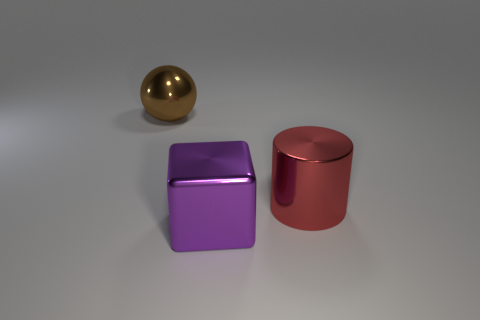What is the big thing that is in front of the large object that is to the right of the large object that is in front of the red cylinder made of?
Give a very brief answer. Metal. What number of big purple blocks are there?
Your response must be concise. 1. What number of cyan things are metallic cylinders or spheres?
Your answer should be very brief. 0. How many other objects are the same shape as the purple metal thing?
Provide a succinct answer. 0. How many big things are either brown objects or cubes?
Provide a succinct answer. 2. What number of metallic things are either yellow balls or large objects?
Offer a terse response. 3. There is a object that is left of the large purple shiny object; is there a big metallic block that is in front of it?
Your answer should be compact. Yes. How many large things are right of the large brown sphere and behind the purple block?
Your response must be concise. 1. What number of large gray spheres have the same material as the brown thing?
Your answer should be very brief. 0. There is a metallic thing on the left side of the metal thing in front of the large metal cylinder; how big is it?
Provide a short and direct response. Large. 